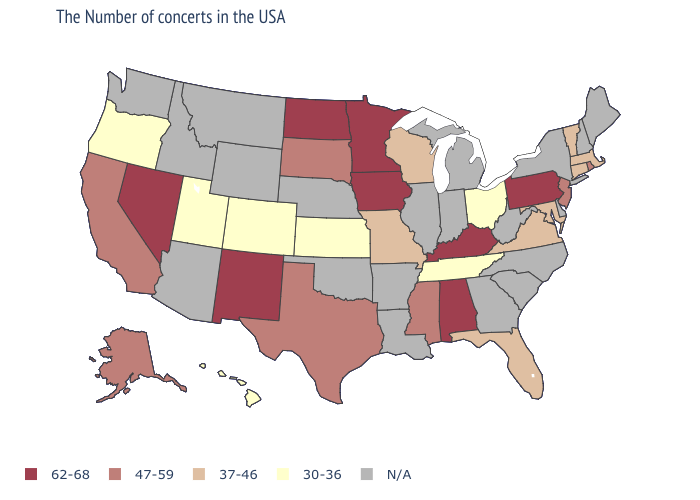Name the states that have a value in the range 30-36?
Write a very short answer. Ohio, Tennessee, Kansas, Colorado, Utah, Oregon, Hawaii. What is the value of Pennsylvania?
Concise answer only. 62-68. Name the states that have a value in the range 37-46?
Quick response, please. Massachusetts, Vermont, Connecticut, Maryland, Virginia, Florida, Wisconsin, Missouri. What is the value of North Carolina?
Answer briefly. N/A. Among the states that border Delaware , which have the highest value?
Answer briefly. Pennsylvania. Is the legend a continuous bar?
Give a very brief answer. No. Name the states that have a value in the range N/A?
Give a very brief answer. Maine, New Hampshire, New York, Delaware, North Carolina, South Carolina, West Virginia, Georgia, Michigan, Indiana, Illinois, Louisiana, Arkansas, Nebraska, Oklahoma, Wyoming, Montana, Arizona, Idaho, Washington. Name the states that have a value in the range 30-36?
Short answer required. Ohio, Tennessee, Kansas, Colorado, Utah, Oregon, Hawaii. Among the states that border Nebraska , does Kansas have the lowest value?
Quick response, please. Yes. What is the value of Kentucky?
Give a very brief answer. 62-68. Name the states that have a value in the range 30-36?
Quick response, please. Ohio, Tennessee, Kansas, Colorado, Utah, Oregon, Hawaii. Does Utah have the highest value in the West?
Answer briefly. No. Name the states that have a value in the range 62-68?
Answer briefly. Pennsylvania, Kentucky, Alabama, Minnesota, Iowa, North Dakota, New Mexico, Nevada. Name the states that have a value in the range N/A?
Write a very short answer. Maine, New Hampshire, New York, Delaware, North Carolina, South Carolina, West Virginia, Georgia, Michigan, Indiana, Illinois, Louisiana, Arkansas, Nebraska, Oklahoma, Wyoming, Montana, Arizona, Idaho, Washington. 